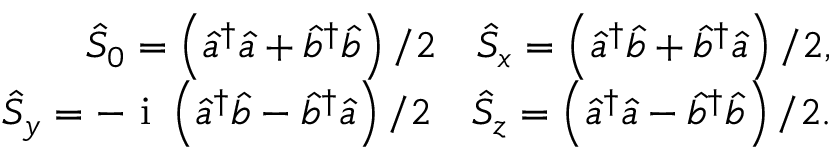Convert formula to latex. <formula><loc_0><loc_0><loc_500><loc_500>\begin{array} { r } { \hat { S } _ { 0 } = \left ( \hat { a } ^ { \dagger } \hat { a } + \hat { b } ^ { \dagger } \hat { b } \right ) / 2 \quad \hat { S } _ { x } = \left ( \hat { a } ^ { \dagger } \hat { b } + \hat { b } ^ { \dagger } \hat { a } \right ) / 2 , } \\ { \hat { S } _ { y } = - i \left ( \hat { a } ^ { \dagger } \hat { b } - \hat { b } ^ { \dagger } \hat { a } \right ) / 2 \quad \hat { S } _ { z } = \left ( \hat { a } ^ { \dagger } \hat { a } - \hat { b } ^ { \dagger } \hat { b } \right ) / 2 . } \end{array}</formula> 